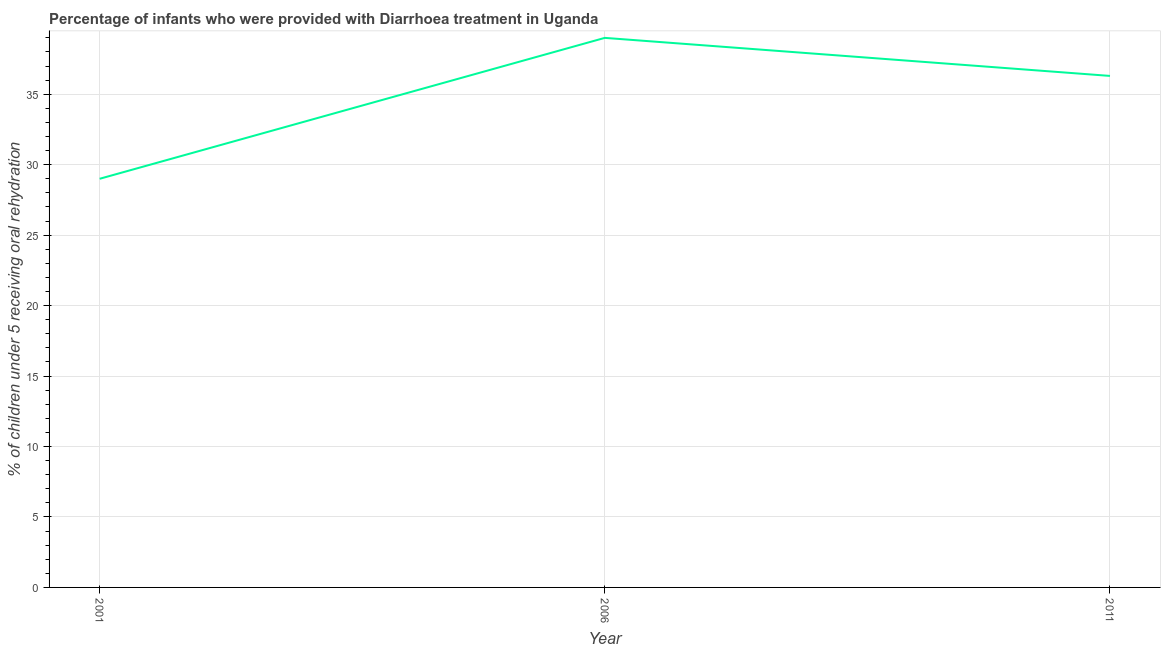Across all years, what is the maximum percentage of children who were provided with treatment diarrhoea?
Provide a short and direct response. 39. In which year was the percentage of children who were provided with treatment diarrhoea minimum?
Keep it short and to the point. 2001. What is the sum of the percentage of children who were provided with treatment diarrhoea?
Offer a very short reply. 104.3. What is the difference between the percentage of children who were provided with treatment diarrhoea in 2001 and 2011?
Make the answer very short. -7.3. What is the average percentage of children who were provided with treatment diarrhoea per year?
Give a very brief answer. 34.77. What is the median percentage of children who were provided with treatment diarrhoea?
Offer a terse response. 36.3. Do a majority of the years between 2001 and 2006 (inclusive) have percentage of children who were provided with treatment diarrhoea greater than 17 %?
Your response must be concise. Yes. What is the ratio of the percentage of children who were provided with treatment diarrhoea in 2006 to that in 2011?
Provide a short and direct response. 1.07. Is the difference between the percentage of children who were provided with treatment diarrhoea in 2001 and 2006 greater than the difference between any two years?
Ensure brevity in your answer.  Yes. What is the difference between the highest and the second highest percentage of children who were provided with treatment diarrhoea?
Offer a very short reply. 2.7. Is the sum of the percentage of children who were provided with treatment diarrhoea in 2001 and 2011 greater than the maximum percentage of children who were provided with treatment diarrhoea across all years?
Keep it short and to the point. Yes. What is the difference between two consecutive major ticks on the Y-axis?
Ensure brevity in your answer.  5. Are the values on the major ticks of Y-axis written in scientific E-notation?
Keep it short and to the point. No. Does the graph contain grids?
Your response must be concise. Yes. What is the title of the graph?
Your answer should be very brief. Percentage of infants who were provided with Diarrhoea treatment in Uganda. What is the label or title of the X-axis?
Provide a short and direct response. Year. What is the label or title of the Y-axis?
Your answer should be compact. % of children under 5 receiving oral rehydration. What is the % of children under 5 receiving oral rehydration of 2001?
Make the answer very short. 29. What is the % of children under 5 receiving oral rehydration of 2006?
Your response must be concise. 39. What is the % of children under 5 receiving oral rehydration in 2011?
Provide a short and direct response. 36.3. What is the difference between the % of children under 5 receiving oral rehydration in 2001 and 2006?
Your answer should be compact. -10. What is the ratio of the % of children under 5 receiving oral rehydration in 2001 to that in 2006?
Your response must be concise. 0.74. What is the ratio of the % of children under 5 receiving oral rehydration in 2001 to that in 2011?
Offer a very short reply. 0.8. What is the ratio of the % of children under 5 receiving oral rehydration in 2006 to that in 2011?
Provide a short and direct response. 1.07. 